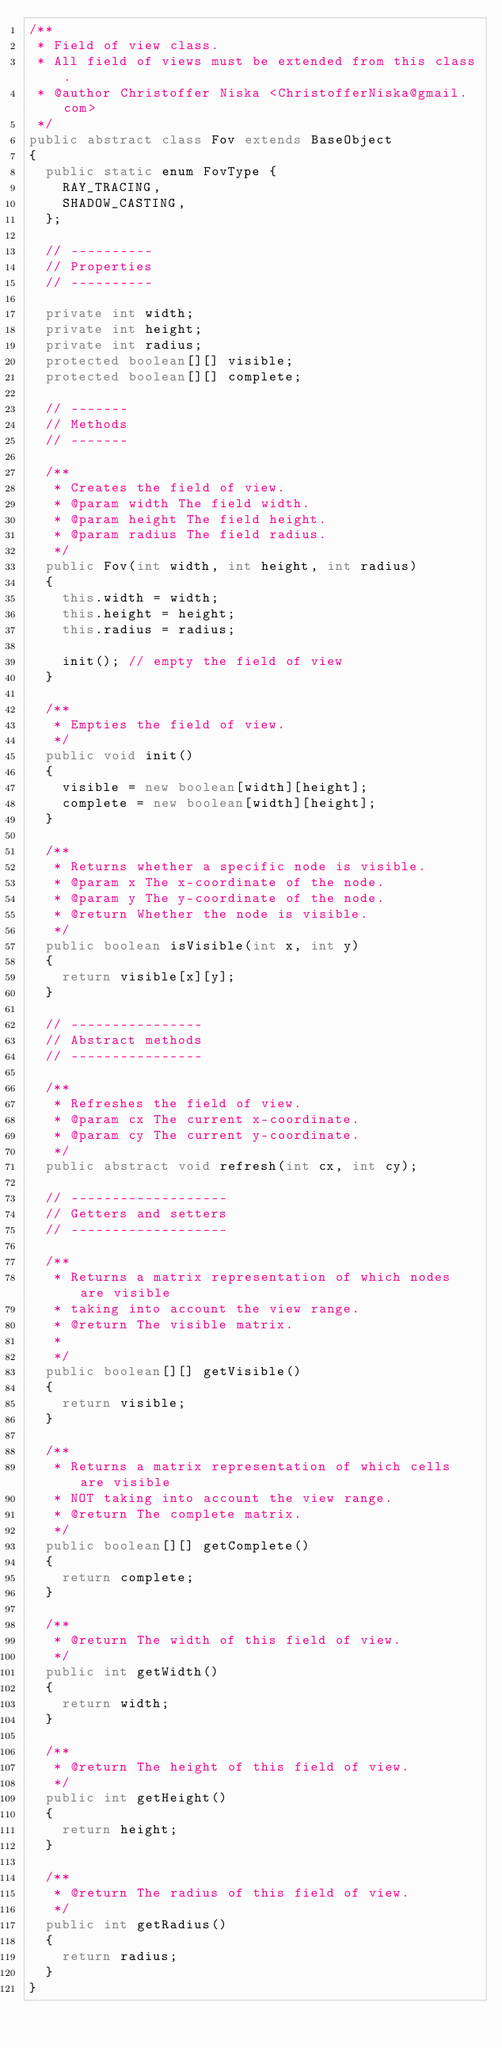Convert code to text. <code><loc_0><loc_0><loc_500><loc_500><_Java_>/**
 * Field of view class.
 * All field of views must be extended from this class.
 * @author Christoffer Niska <ChristofferNiska@gmail.com>
 */
public abstract class Fov extends BaseObject
{
	public static enum FovType {
		RAY_TRACING,
		SHADOW_CASTING,
	};

	// ----------
	// Properties
	// ----------

	private int width;
	private int height;
	private int radius;
	protected boolean[][] visible;
	protected boolean[][] complete;

	// -------
	// Methods
	// -------

	/**
	 * Creates the field of view.
	 * @param width The field width.
	 * @param height The field height.
	 * @param radius The field radius.
	 */
	public Fov(int width, int height, int radius)
	{
		this.width = width;
		this.height = height;
		this.radius = radius;

		init(); // empty the field of view
	}

	/**
	 * Empties the field of view.
	 */
	public void init()
	{
		visible = new boolean[width][height];
		complete = new boolean[width][height];
	}

	/**
	 * Returns whether a specific node is visible.
	 * @param x The x-coordinate of the node.
	 * @param y The y-coordinate of the node.
	 * @return Whether the node is visible.
	 */
	public boolean isVisible(int x, int y)
	{
		return visible[x][y];
	}

	// ----------------
	// Abstract methods
	// ----------------
	
	/**
	 * Refreshes the field of view.
	 * @param cx The current x-coordinate.
	 * @param cy The current y-coordinate.
	 */
	public abstract void refresh(int cx, int cy);

	// -------------------
	// Getters and setters
	// -------------------

	/**
	 * Returns a matrix representation of which nodes are visible
	 * taking into account the view range.
	 * @return The visible matrix.
	 *
	 */
	public boolean[][] getVisible()
	{
		return visible;
	}

	/**
	 * Returns a matrix representation of which cells are visible
	 * NOT taking into account the view range.
	 * @return The complete matrix.
	 */
	public boolean[][] getComplete()
	{
		return complete;
	}

	/**
	 * @return The width of this field of view.
	 */
	public int getWidth()
	{
		return width;
	}

	/**
	 * @return The height of this field of view.
	 */
	public int getHeight()
	{
		return height;
	}

	/**
	 * @return The radius of this field of view.
	 */
	public int getRadius()
	{
		return radius;
	}
}
</code> 